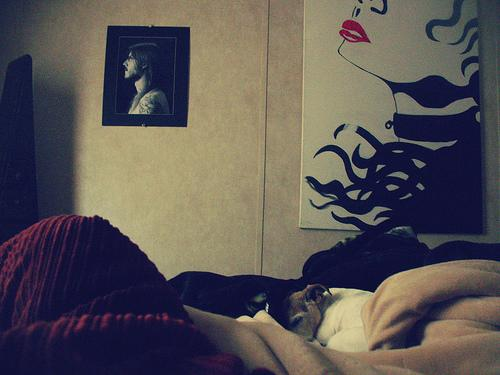Based on the image, what emotions could it evoke in a viewer? The image could evoke curiosity, interest, or admiration for art and the depicted subjects. Analyze the complexity of the depicted scene in the image. The scene is intricate with various objects, including artwork, a dog, blankets, and a woman's features, all contributing to overall complexity and stimulating visual interest. List the objects that can be found on the wall of the image. Picture hanging on wall, black frame around picture, picture of man, large picture hanging on wall, red lips on picture, a painting called "this is a painting," and black and white painting. What objects can be found in the image? Picture on wall, man, dog, red blanket, tan blanket, large picture, red lips, painting, choker, photo, pillow, wall, and a woman. How many objects are there in the image related to art or decoration? There are nine objects: picture hanging on wall, black frame around picture, picture of man, large picture hanging on wall, red lips on picture, a painting called "this is a painting," black and white painting, painting called "this is a painting," and a photo. Describe the interaction between objects on the bed. A dog is laying on the bed covered with a red blanket and a tan blanket, and there's a pillow nearby. Discuss the features of the image that suggest it's an art piece. There is a picture hanging on the wall, a painting, a black and white photo, and the subject includes red lips, a choker, and images of people. Point out the television placed on the floor next to the large picture hanging on the wall. There is no mention of a television in the image, so the instruction would lead the user to look for an object that is not present in the picture. Could you please find the position of the green parrot sitting on the picture frame? There is no mention of a green parrot in the image, so it would lead the user to look for a non-existent object. Find the height of the purple curtains hanging alongside the picture on the wall. No, it's not mentioned in the image. Do you see a toy car on the bed near the red blanket? There is no mention of a toy car in the image, so asking the user to locate it would mislead them in their search for non-existent objects. 